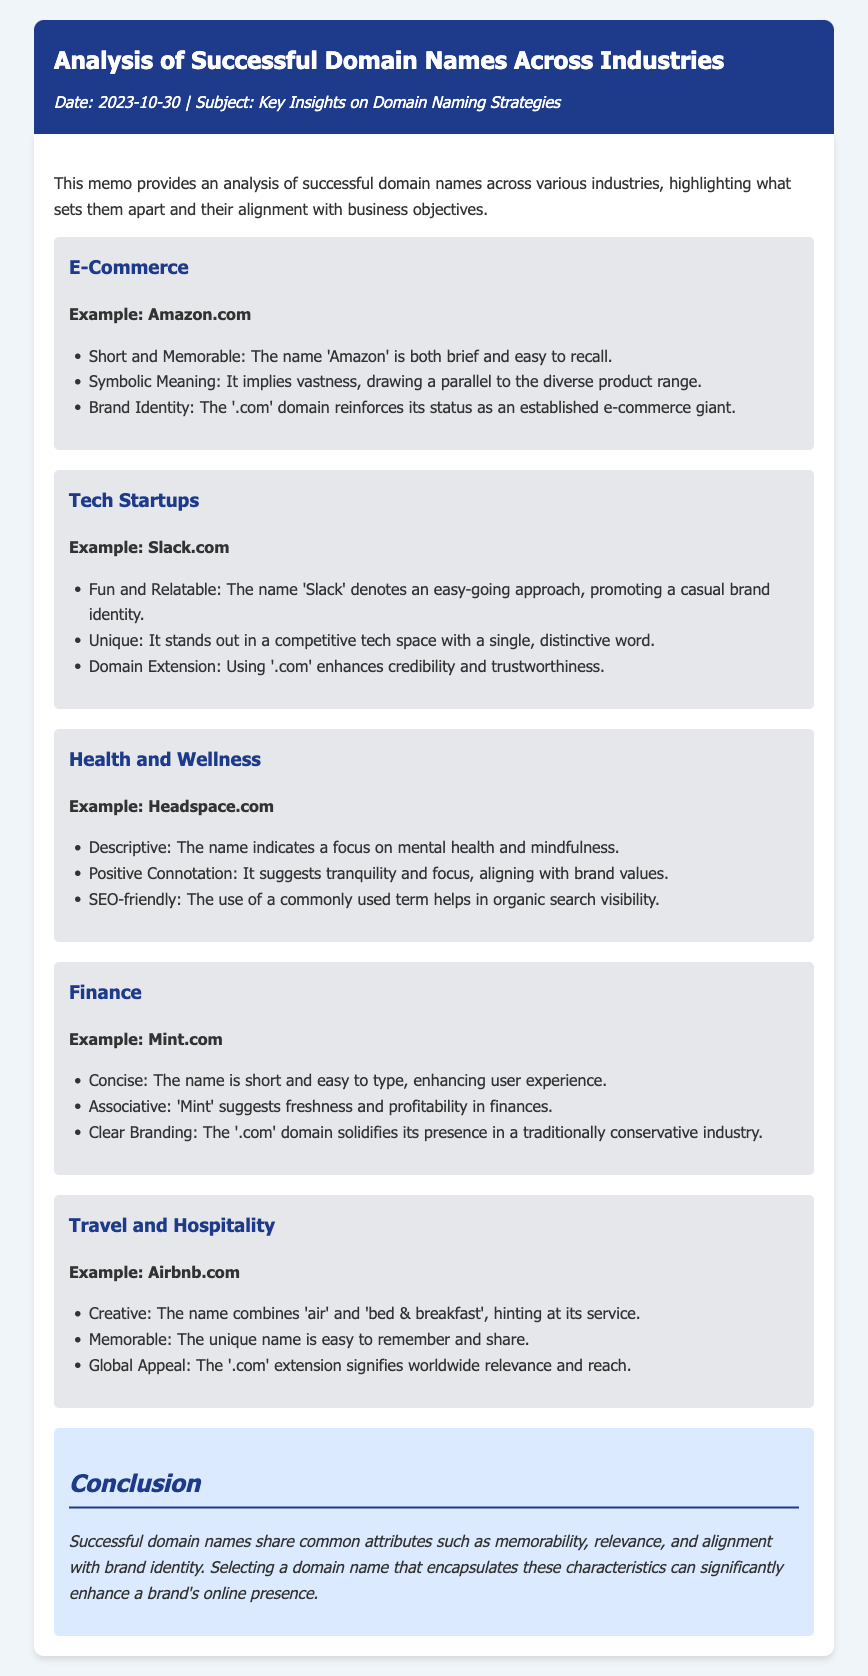What is the date of the memo? The date of the memo is clearly stated in the header section, which reads 2023-10-30.
Answer: 2023-10-30 What is an example domain name from the E-Commerce industry? The document provides 'Amazon.com' as a successful example of a domain name in the E-Commerce industry.
Answer: Amazon.com How is the domain name 'Slack' described? The memo states that 'Slack' is characterized as fun and relatable, promoting a casual brand identity.
Answer: Fun and Relatable What does the name 'Mint' suggest according to the document? The document notes that 'Mint' suggests freshness and profitability in finances.
Answer: Freshness and profitability Which domain name uses a term related to mental health? The document indicates 'Headspace.com' as a domain name associated with mental health.
Answer: Headspace.com What common attribute do successful domain names share? The conclusion highlights that successful domain names share attributes such as memorability, relevance, and alignment with brand identity.
Answer: Memorability What is the domain extension used by all examples listed in the document? Upon review of the examples provided, it is noted that all utilize the '.com' domain extension, enhancing credibility.
Answer: .com How does 'Airbnb' relate its name to its service? The document states that 'Airbnb' creatively combines 'air' and 'bed & breakfast,' hinting at its hospitality service.
Answer: Combines air and bed & breakfast What overall insight does the conclusion offer regarding domain names? The conclusion emphasizes the importance of selecting a domain name that encapsulates key characteristics to enhance online presence.
Answer: Enhance online presence 